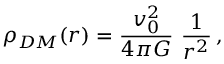<formula> <loc_0><loc_0><loc_500><loc_500>\rho _ { D M } ( r ) = \frac { v _ { 0 } ^ { 2 } } { 4 \pi G } \frac { 1 } { r ^ { 2 } } \, ,</formula> 